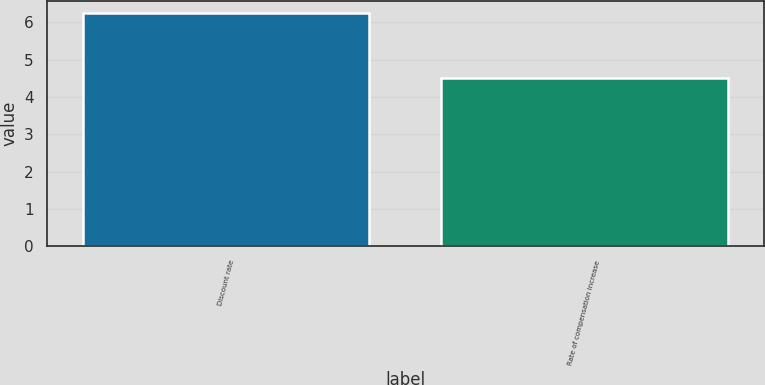Convert chart. <chart><loc_0><loc_0><loc_500><loc_500><bar_chart><fcel>Discount rate<fcel>Rate of compensation increase<nl><fcel>6.25<fcel>4.5<nl></chart> 